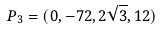<formula> <loc_0><loc_0><loc_500><loc_500>P _ { 3 } = ( 0 , - 7 2 , 2 \sqrt { 3 } , 1 2 )</formula> 